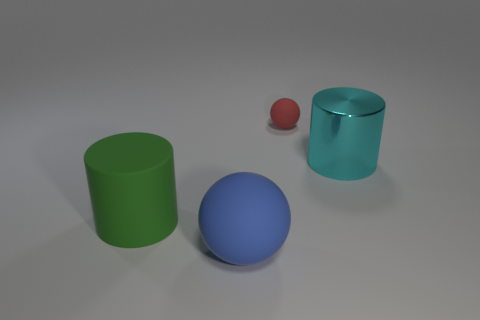Add 2 big blue things. How many objects exist? 6 Add 2 cylinders. How many cylinders are left? 4 Add 1 red things. How many red things exist? 2 Subtract 1 red balls. How many objects are left? 3 Subtract all big yellow cylinders. Subtract all metal cylinders. How many objects are left? 3 